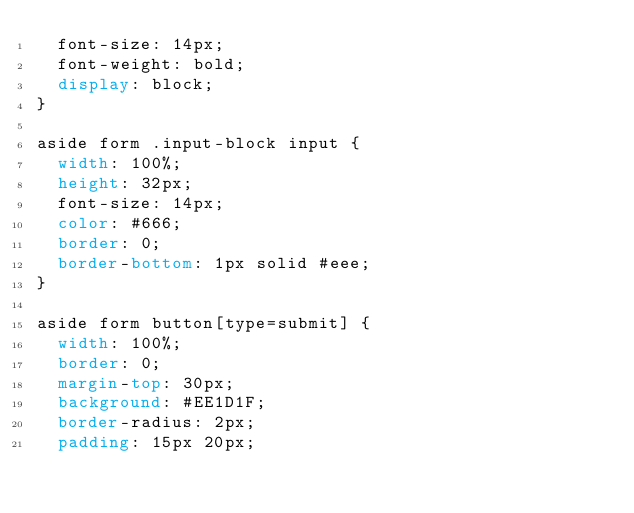Convert code to text. <code><loc_0><loc_0><loc_500><loc_500><_CSS_>  font-size: 14px;
  font-weight: bold;
  display: block;
}

aside form .input-block input {
  width: 100%;
  height: 32px;
  font-size: 14px;
  color: #666;
  border: 0;
  border-bottom: 1px solid #eee;
}

aside form button[type=submit] {
  width: 100%;
  border: 0;
  margin-top: 30px;
  background: #EE1D1F;
  border-radius: 2px;
  padding: 15px 20px;</code> 